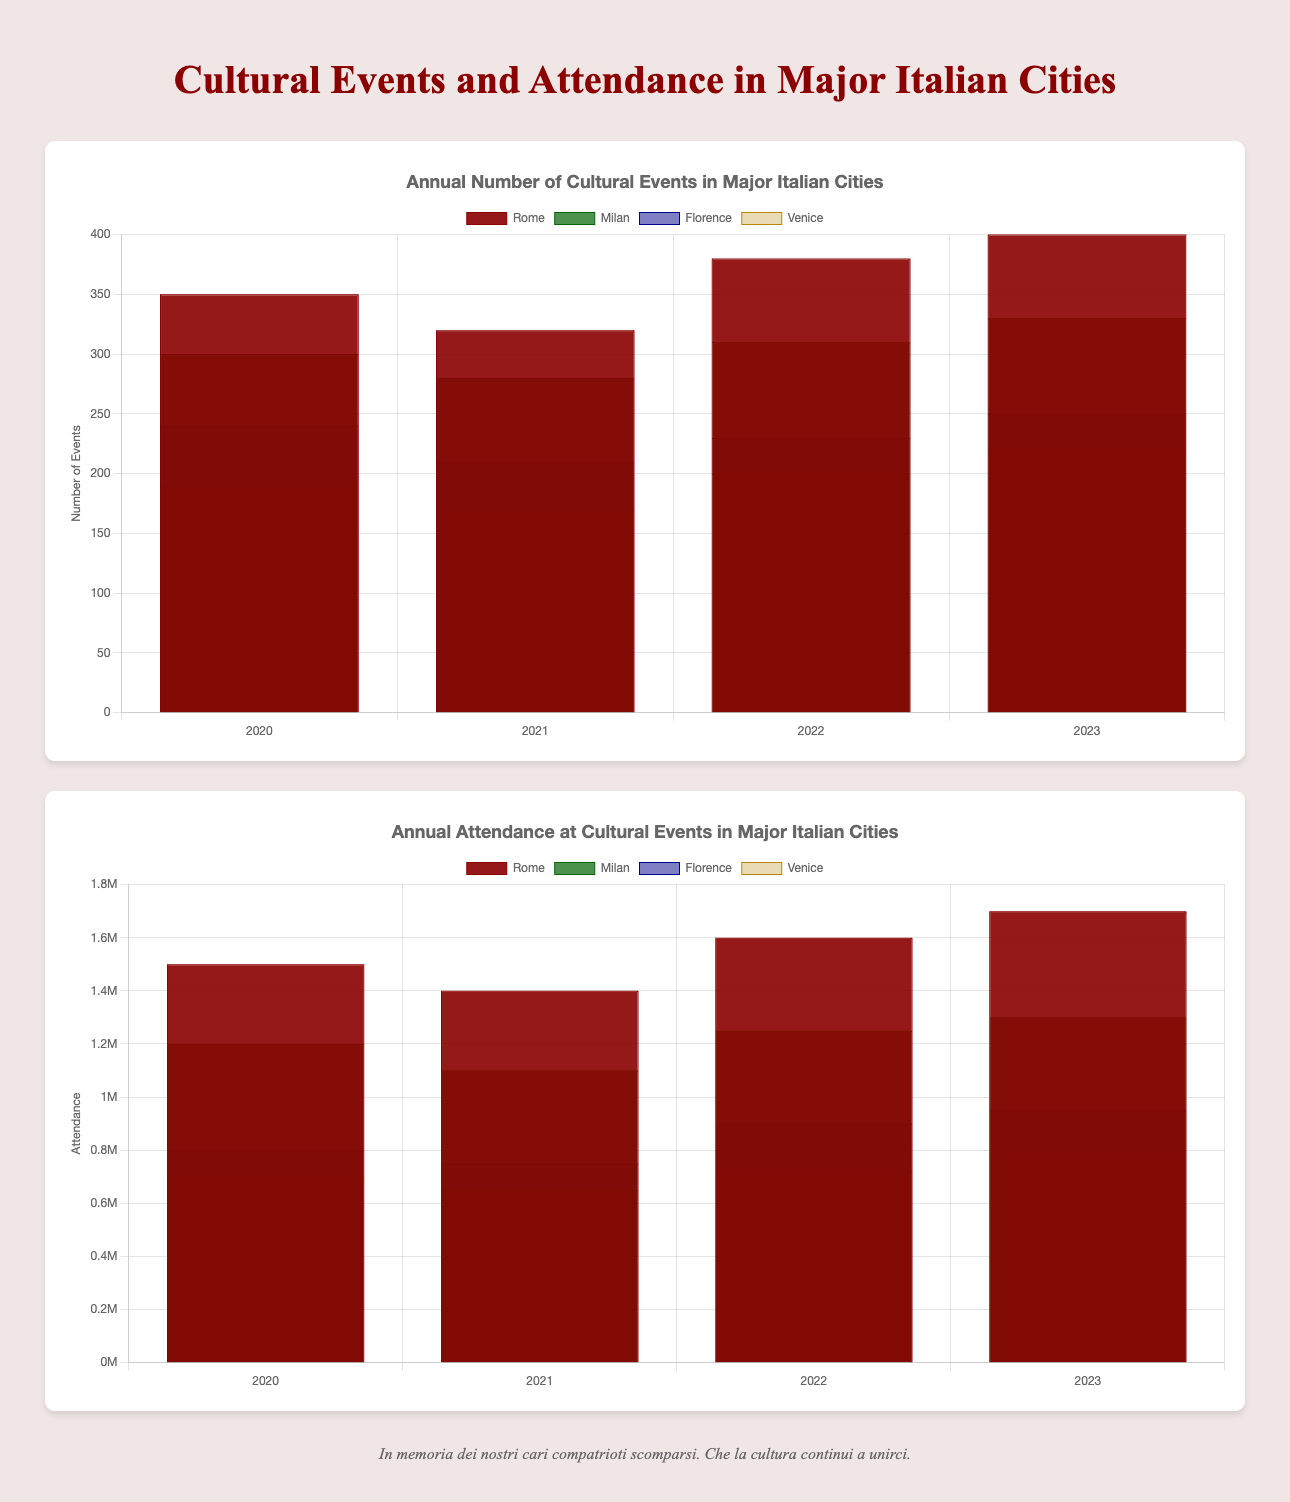What city had the highest number of cultural events in 2023? By looking at the height of the bars representing the number of cultural events in 2023, identify the city with the tallest bar.
Answer: Rome How did Milan's attendance rate in 2022 compare to 2023? Compare the heights of the bars representing Milan's attendance for the years 2022 and 2023. The 2023 bar is taller than the 2022 bar indicating an increase.
Answer: Increased Which city had the lowest attendance in 2020? By examining the heights of the bars representing attendance in 2020, identify the city with the shortest bar.
Answer: Venice Calculate the total number of cultural events held in Florence from 2020 to 2023. Sum the heights of the bars representing the number of cultural events in Florence for each year: 240 (2020) + 210 (2021) + 230 (2022) + 250 (2023).
Answer: 930 What was the average annual attendance at cultural events in Milan between 2020 and 2023? Calculate the average by summing the attendance for each year: 1200000 (2020) + 1100000 (2021) + 1250000 (2022) + 1300000 (2023), and then divide by the number of years (4). Average = (1200000 + 1100000 + 1250000 + 1300000) / 4.
Answer: 1212500 Between 2020 and 2021, which city saw the greatest drop in the number of cultural events? Subtract 2021 values from 2020 values for each city, and identify the largest negative result: Rome (350-320=30), Milan (300-280=20), Florence (240-210=30), Venice (190-170=20). Both Rome and Florence saw the greatest drop (30).
Answer: Rome and Florence Did Rome have a higher attendance rate in 2021 or Florence in 2023? Compare the heights of the bars representing Rome's attendance in 2021 with Florence's attendance in 2023. Florence 2023's bar is shorter (950000) compared to Rome's attendance in 2021 (1400000).
Answer: Rome in 2021 Which year had the most significant overall attendance across all cities? Sum the heights of the bars representing attendance for each year and identify the highest total: 1500000+1200000+800000+700000=4200000 (2020), 1400000+1100000+750000+650000=3900000 (2021), 1600000+1250000+900000+720000=4470000 (2022), 1700000+1300000+950000+780000=4730000 (2023).
Answer: 2023 